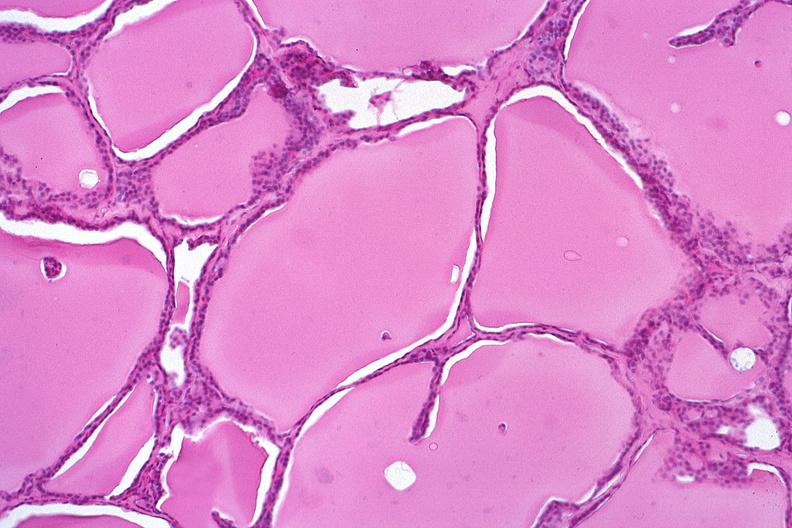where is this part in the figure?
Answer the question using a single word or phrase. Endocrine system 